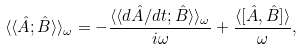<formula> <loc_0><loc_0><loc_500><loc_500>\langle \langle \hat { A } ; \hat { B } \rangle \rangle _ { \omega } = - \frac { \langle \langle d \hat { A } / d t ; \hat { B } \rangle \rangle _ { \omega } } { i \omega } + \frac { \langle [ \hat { A } , \hat { B } ] \rangle } { \omega } ,</formula> 